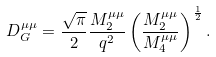Convert formula to latex. <formula><loc_0><loc_0><loc_500><loc_500>D _ { G } ^ { \mu \mu } = \frac { \sqrt { \pi } } { 2 } \frac { M _ { 2 } ^ { \mu \mu } } { q ^ { 2 } } \left ( \frac { M _ { 2 } ^ { \mu \mu } } { M _ { 4 } ^ { \mu \mu } } \right ) ^ { \frac { 1 } { 2 } } .</formula> 